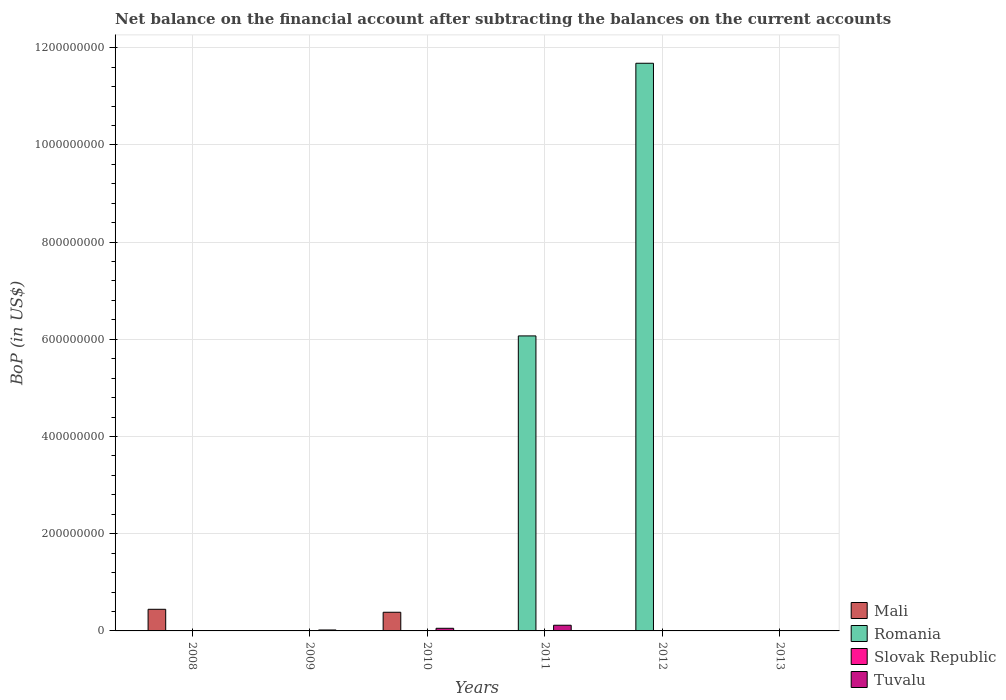How many different coloured bars are there?
Your answer should be compact. 3. Are the number of bars per tick equal to the number of legend labels?
Your response must be concise. No. Are the number of bars on each tick of the X-axis equal?
Make the answer very short. No. How many bars are there on the 1st tick from the left?
Keep it short and to the point. 2. How many bars are there on the 6th tick from the right?
Your answer should be compact. 2. What is the label of the 1st group of bars from the left?
Offer a terse response. 2008. What is the Balance of Payments in Slovak Republic in 2013?
Keep it short and to the point. 0. Across all years, what is the maximum Balance of Payments in Tuvalu?
Make the answer very short. 1.17e+07. Across all years, what is the minimum Balance of Payments in Romania?
Provide a succinct answer. 0. What is the total Balance of Payments in Slovak Republic in the graph?
Offer a very short reply. 0. What is the average Balance of Payments in Mali per year?
Your response must be concise. 1.38e+07. In the year 2011, what is the difference between the Balance of Payments in Tuvalu and Balance of Payments in Romania?
Offer a terse response. -5.95e+08. What is the ratio of the Balance of Payments in Tuvalu in 2009 to that in 2010?
Ensure brevity in your answer.  0.36. What is the difference between the highest and the second highest Balance of Payments in Tuvalu?
Provide a succinct answer. 6.27e+06. What is the difference between the highest and the lowest Balance of Payments in Tuvalu?
Offer a very short reply. 1.17e+07. In how many years, is the Balance of Payments in Tuvalu greater than the average Balance of Payments in Tuvalu taken over all years?
Provide a succinct answer. 2. Is the sum of the Balance of Payments in Tuvalu in 2009 and 2010 greater than the maximum Balance of Payments in Mali across all years?
Provide a succinct answer. No. Are all the bars in the graph horizontal?
Offer a terse response. No. Are the values on the major ticks of Y-axis written in scientific E-notation?
Provide a succinct answer. No. Does the graph contain grids?
Provide a short and direct response. Yes. How are the legend labels stacked?
Make the answer very short. Vertical. What is the title of the graph?
Give a very brief answer. Net balance on the financial account after subtracting the balances on the current accounts. What is the label or title of the Y-axis?
Provide a succinct answer. BoP (in US$). What is the BoP (in US$) in Mali in 2008?
Offer a very short reply. 4.45e+07. What is the BoP (in US$) of Tuvalu in 2008?
Your answer should be compact. 6.64e+05. What is the BoP (in US$) of Slovak Republic in 2009?
Give a very brief answer. 0. What is the BoP (in US$) in Tuvalu in 2009?
Offer a terse response. 1.93e+06. What is the BoP (in US$) in Mali in 2010?
Provide a succinct answer. 3.84e+07. What is the BoP (in US$) of Slovak Republic in 2010?
Offer a very short reply. 0. What is the BoP (in US$) in Tuvalu in 2010?
Offer a terse response. 5.42e+06. What is the BoP (in US$) in Mali in 2011?
Offer a very short reply. 0. What is the BoP (in US$) in Romania in 2011?
Provide a short and direct response. 6.07e+08. What is the BoP (in US$) in Tuvalu in 2011?
Keep it short and to the point. 1.17e+07. What is the BoP (in US$) of Romania in 2012?
Make the answer very short. 1.17e+09. What is the BoP (in US$) of Romania in 2013?
Provide a succinct answer. 0. What is the BoP (in US$) in Slovak Republic in 2013?
Provide a succinct answer. 0. Across all years, what is the maximum BoP (in US$) in Mali?
Your answer should be very brief. 4.45e+07. Across all years, what is the maximum BoP (in US$) of Romania?
Provide a succinct answer. 1.17e+09. Across all years, what is the maximum BoP (in US$) in Tuvalu?
Your answer should be very brief. 1.17e+07. Across all years, what is the minimum BoP (in US$) of Mali?
Provide a short and direct response. 0. Across all years, what is the minimum BoP (in US$) of Tuvalu?
Make the answer very short. 0. What is the total BoP (in US$) of Mali in the graph?
Provide a short and direct response. 8.29e+07. What is the total BoP (in US$) in Romania in the graph?
Your answer should be compact. 1.78e+09. What is the total BoP (in US$) of Slovak Republic in the graph?
Your answer should be very brief. 0. What is the total BoP (in US$) of Tuvalu in the graph?
Your answer should be compact. 1.97e+07. What is the difference between the BoP (in US$) in Tuvalu in 2008 and that in 2009?
Give a very brief answer. -1.27e+06. What is the difference between the BoP (in US$) in Mali in 2008 and that in 2010?
Your answer should be compact. 6.10e+06. What is the difference between the BoP (in US$) in Tuvalu in 2008 and that in 2010?
Your answer should be very brief. -4.76e+06. What is the difference between the BoP (in US$) in Tuvalu in 2008 and that in 2011?
Your answer should be very brief. -1.10e+07. What is the difference between the BoP (in US$) of Tuvalu in 2009 and that in 2010?
Your answer should be compact. -3.49e+06. What is the difference between the BoP (in US$) of Tuvalu in 2009 and that in 2011?
Your answer should be very brief. -9.76e+06. What is the difference between the BoP (in US$) of Tuvalu in 2010 and that in 2011?
Your answer should be compact. -6.27e+06. What is the difference between the BoP (in US$) in Romania in 2011 and that in 2012?
Offer a very short reply. -5.61e+08. What is the difference between the BoP (in US$) in Mali in 2008 and the BoP (in US$) in Tuvalu in 2009?
Offer a terse response. 4.26e+07. What is the difference between the BoP (in US$) of Mali in 2008 and the BoP (in US$) of Tuvalu in 2010?
Provide a short and direct response. 3.91e+07. What is the difference between the BoP (in US$) in Mali in 2008 and the BoP (in US$) in Romania in 2011?
Your response must be concise. -5.62e+08. What is the difference between the BoP (in US$) in Mali in 2008 and the BoP (in US$) in Tuvalu in 2011?
Offer a terse response. 3.28e+07. What is the difference between the BoP (in US$) of Mali in 2008 and the BoP (in US$) of Romania in 2012?
Keep it short and to the point. -1.12e+09. What is the difference between the BoP (in US$) of Mali in 2010 and the BoP (in US$) of Romania in 2011?
Your answer should be very brief. -5.69e+08. What is the difference between the BoP (in US$) in Mali in 2010 and the BoP (in US$) in Tuvalu in 2011?
Your response must be concise. 2.67e+07. What is the difference between the BoP (in US$) of Mali in 2010 and the BoP (in US$) of Romania in 2012?
Make the answer very short. -1.13e+09. What is the average BoP (in US$) in Mali per year?
Offer a very short reply. 1.38e+07. What is the average BoP (in US$) of Romania per year?
Your response must be concise. 2.96e+08. What is the average BoP (in US$) of Slovak Republic per year?
Make the answer very short. 0. What is the average BoP (in US$) of Tuvalu per year?
Your answer should be very brief. 3.29e+06. In the year 2008, what is the difference between the BoP (in US$) in Mali and BoP (in US$) in Tuvalu?
Your answer should be compact. 4.38e+07. In the year 2010, what is the difference between the BoP (in US$) in Mali and BoP (in US$) in Tuvalu?
Ensure brevity in your answer.  3.30e+07. In the year 2011, what is the difference between the BoP (in US$) of Romania and BoP (in US$) of Tuvalu?
Offer a terse response. 5.95e+08. What is the ratio of the BoP (in US$) in Tuvalu in 2008 to that in 2009?
Your response must be concise. 0.34. What is the ratio of the BoP (in US$) of Mali in 2008 to that in 2010?
Make the answer very short. 1.16. What is the ratio of the BoP (in US$) in Tuvalu in 2008 to that in 2010?
Make the answer very short. 0.12. What is the ratio of the BoP (in US$) of Tuvalu in 2008 to that in 2011?
Your response must be concise. 0.06. What is the ratio of the BoP (in US$) in Tuvalu in 2009 to that in 2010?
Ensure brevity in your answer.  0.36. What is the ratio of the BoP (in US$) of Tuvalu in 2009 to that in 2011?
Your response must be concise. 0.17. What is the ratio of the BoP (in US$) of Tuvalu in 2010 to that in 2011?
Give a very brief answer. 0.46. What is the ratio of the BoP (in US$) of Romania in 2011 to that in 2012?
Offer a terse response. 0.52. What is the difference between the highest and the second highest BoP (in US$) of Tuvalu?
Your answer should be very brief. 6.27e+06. What is the difference between the highest and the lowest BoP (in US$) in Mali?
Give a very brief answer. 4.45e+07. What is the difference between the highest and the lowest BoP (in US$) in Romania?
Offer a very short reply. 1.17e+09. What is the difference between the highest and the lowest BoP (in US$) in Tuvalu?
Your answer should be compact. 1.17e+07. 